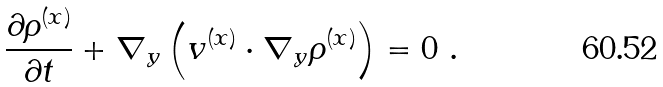Convert formula to latex. <formula><loc_0><loc_0><loc_500><loc_500>\frac { \partial \rho ^ { ( x ) } } { \partial t } + \nabla _ { y } \left ( v ^ { ( x ) } \cdot \nabla _ { y } \rho ^ { ( x ) } \right ) = 0 \ .</formula> 